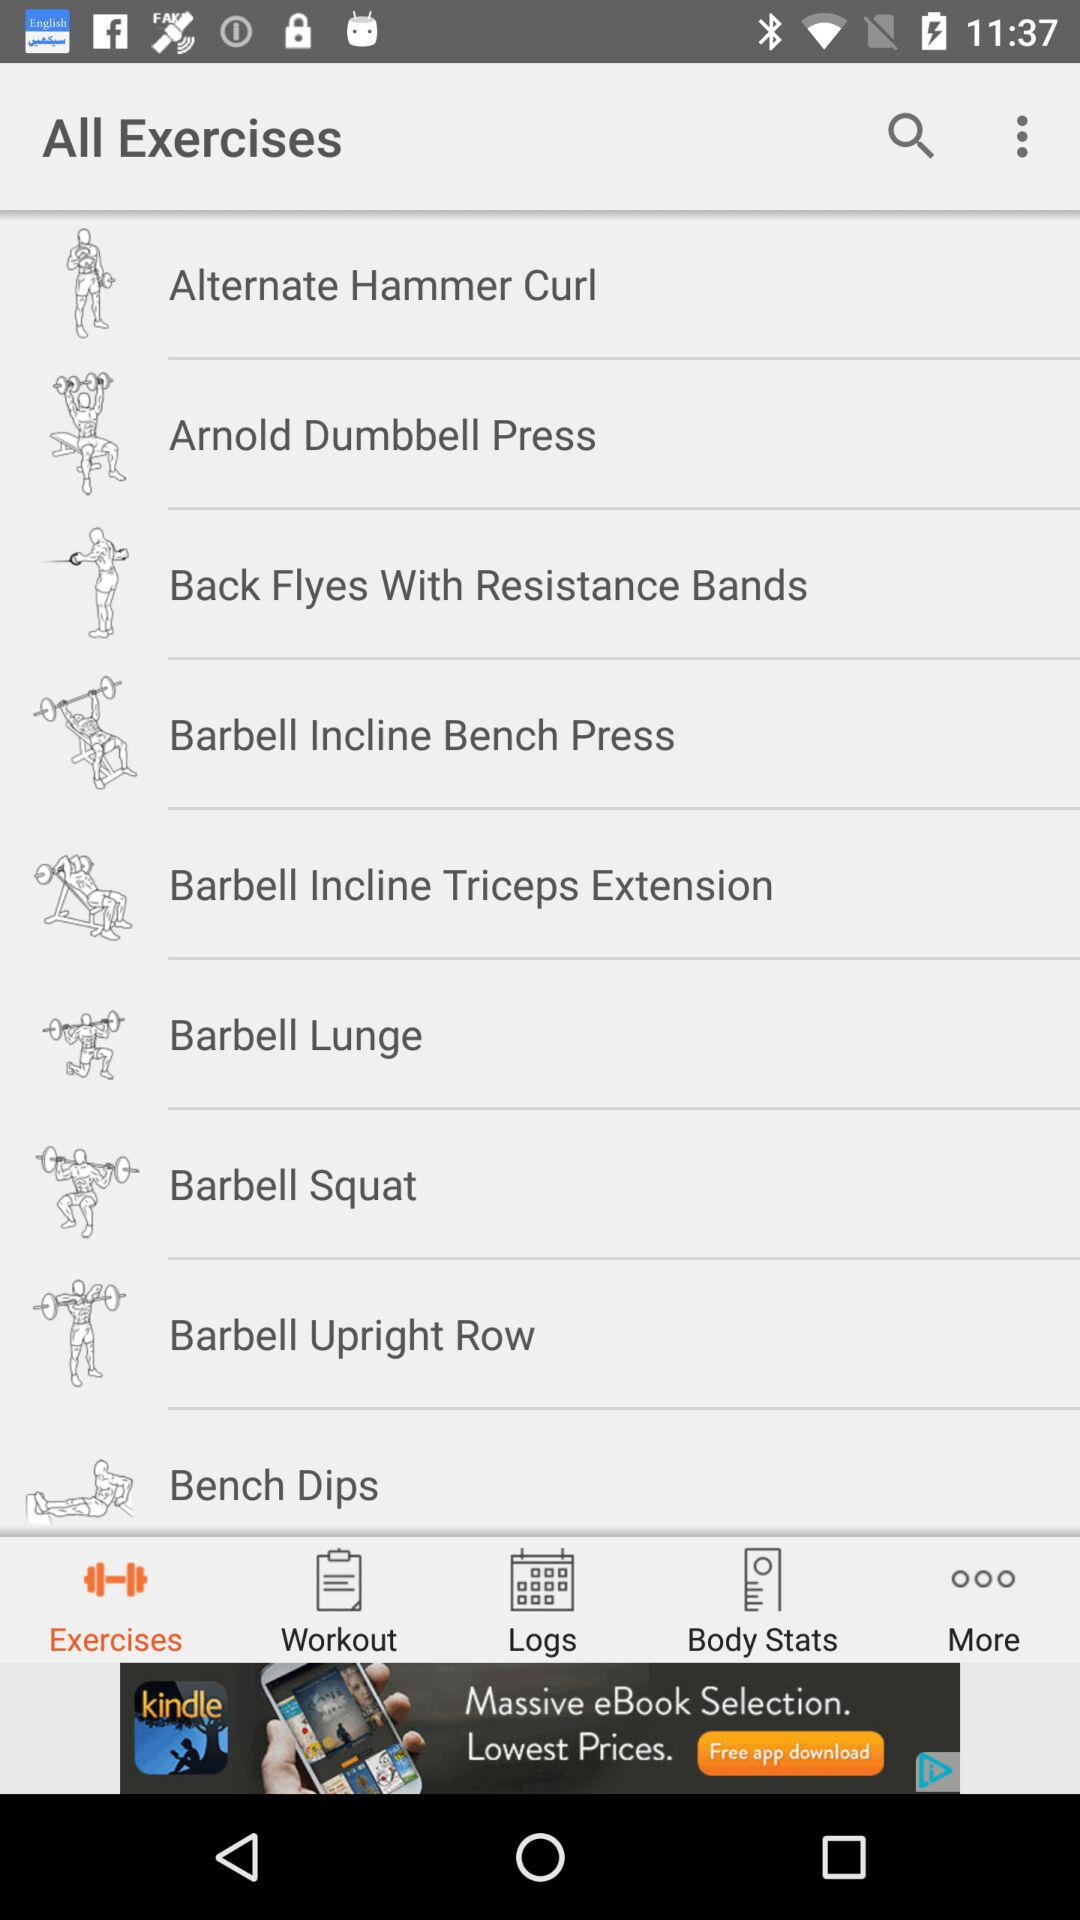What is the list of available exercises? The available exercises are "Alternate Hammer Curl", "Arnold Dumbbell Press", "Back Flyes With Resistance Bands", "Barbell Incline Bench Press", "Barbell Incline Triceps Extension", "Barbell Lunge", "Barbell Squat", "Barbell Upright Row" and "Bench Dips". 